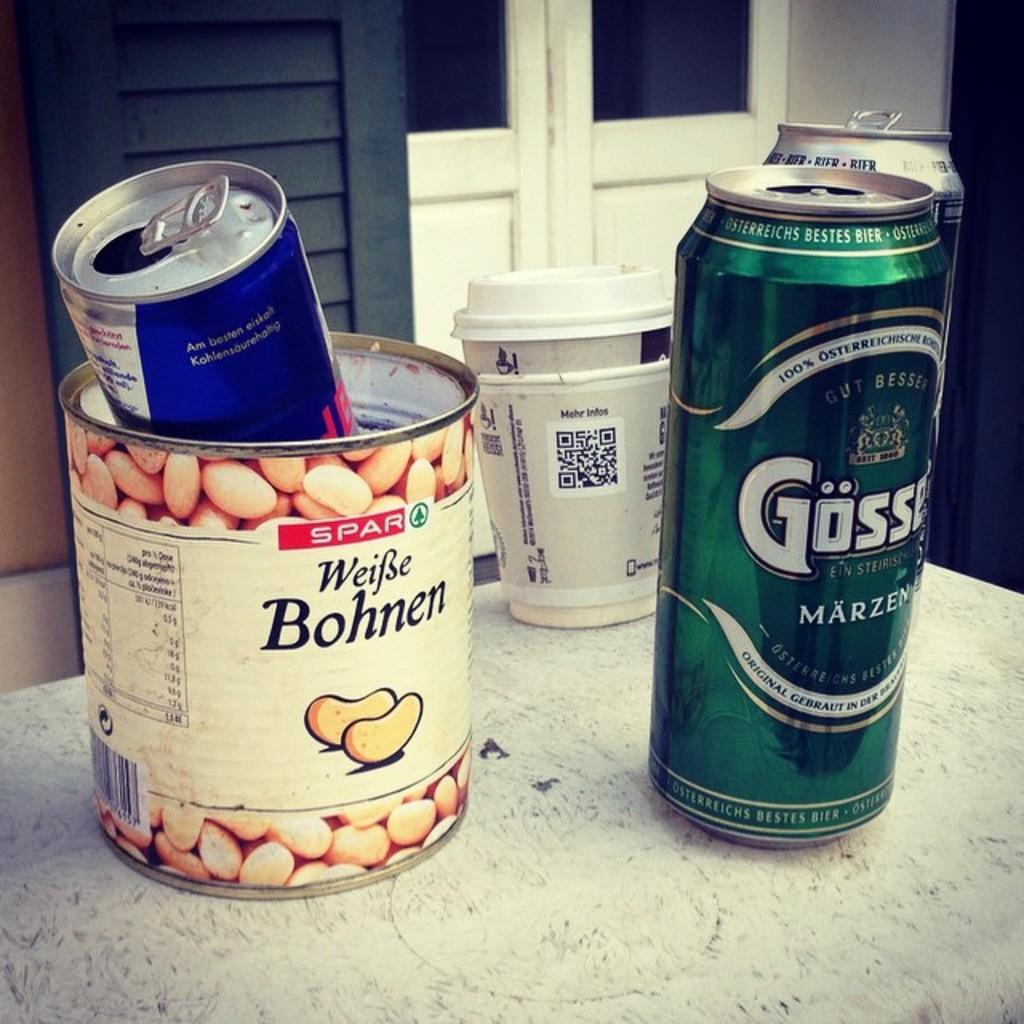<image>
Provide a brief description of the given image. White beans were once contained in this tin can but it now holds a red bull can. 